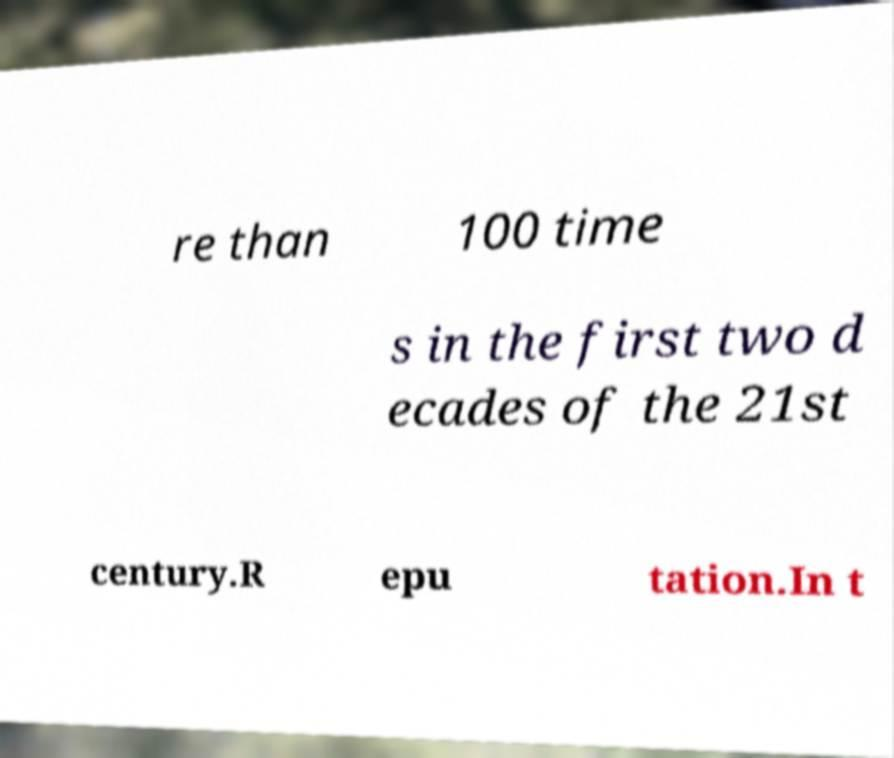Please identify and transcribe the text found in this image. re than 100 time s in the first two d ecades of the 21st century.R epu tation.In t 